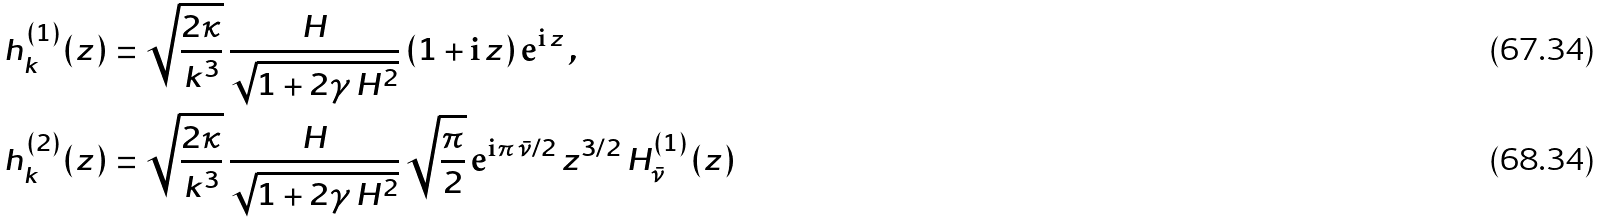Convert formula to latex. <formula><loc_0><loc_0><loc_500><loc_500>h ^ { ( 1 ) } _ { k } ( z ) & = \sqrt { \frac { 2 \kappa } { k ^ { 3 } } } \, \frac { H } { \sqrt { 1 + 2 \gamma \, H ^ { 2 } } } \, ( 1 + \mathrm i \, z ) \, \mathrm e ^ { \mathrm i \, z } \, , \\ h ^ { ( 2 ) } _ { k } ( z ) & = \sqrt { \frac { 2 \kappa } { k ^ { 3 } } } \, \frac { H } { \sqrt { 1 + 2 \gamma \, H ^ { 2 } } } \, \sqrt { \frac { \pi } { 2 } } \, \mathrm e ^ { \mathrm i \pi \, \bar { \nu } / 2 } \, z ^ { 3 / 2 } \, H ^ { ( 1 ) } _ { \bar { \nu } } ( z )</formula> 